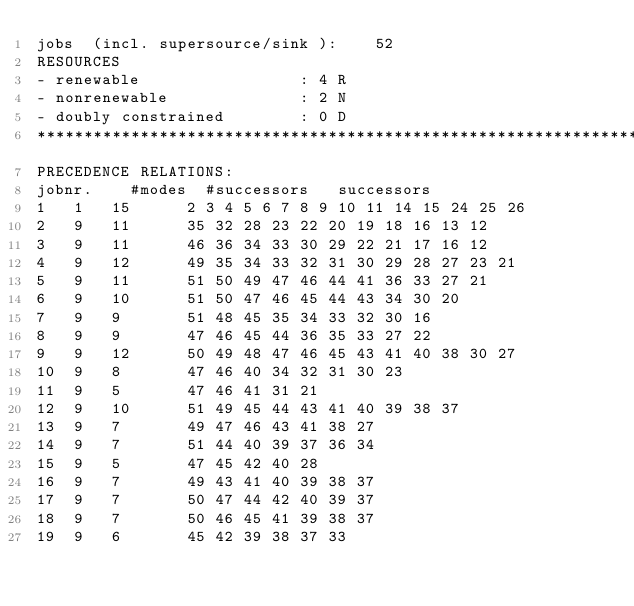Convert code to text. <code><loc_0><loc_0><loc_500><loc_500><_ObjectiveC_>jobs  (incl. supersource/sink ):	52
RESOURCES
- renewable                 : 4 R
- nonrenewable              : 2 N
- doubly constrained        : 0 D
************************************************************************
PRECEDENCE RELATIONS:
jobnr.    #modes  #successors   successors
1	1	15		2 3 4 5 6 7 8 9 10 11 14 15 24 25 26 
2	9	11		35 32 28 23 22 20 19 18 16 13 12 
3	9	11		46 36 34 33 30 29 22 21 17 16 12 
4	9	12		49 35 34 33 32 31 30 29 28 27 23 21 
5	9	11		51 50 49 47 46 44 41 36 33 27 21 
6	9	10		51 50 47 46 45 44 43 34 30 20 
7	9	9		51 48 45 35 34 33 32 30 16 
8	9	9		47 46 45 44 36 35 33 27 22 
9	9	12		50 49 48 47 46 45 43 41 40 38 30 27 
10	9	8		47 46 40 34 32 31 30 23 
11	9	5		47 46 41 31 21 
12	9	10		51 49 45 44 43 41 40 39 38 37 
13	9	7		49 47 46 43 41 38 27 
14	9	7		51 44 40 39 37 36 34 
15	9	5		47 45 42 40 28 
16	9	7		49 43 41 40 39 38 37 
17	9	7		50 47 44 42 40 39 37 
18	9	7		50 46 45 41 39 38 37 
19	9	6		45 42 39 38 37 33 </code> 